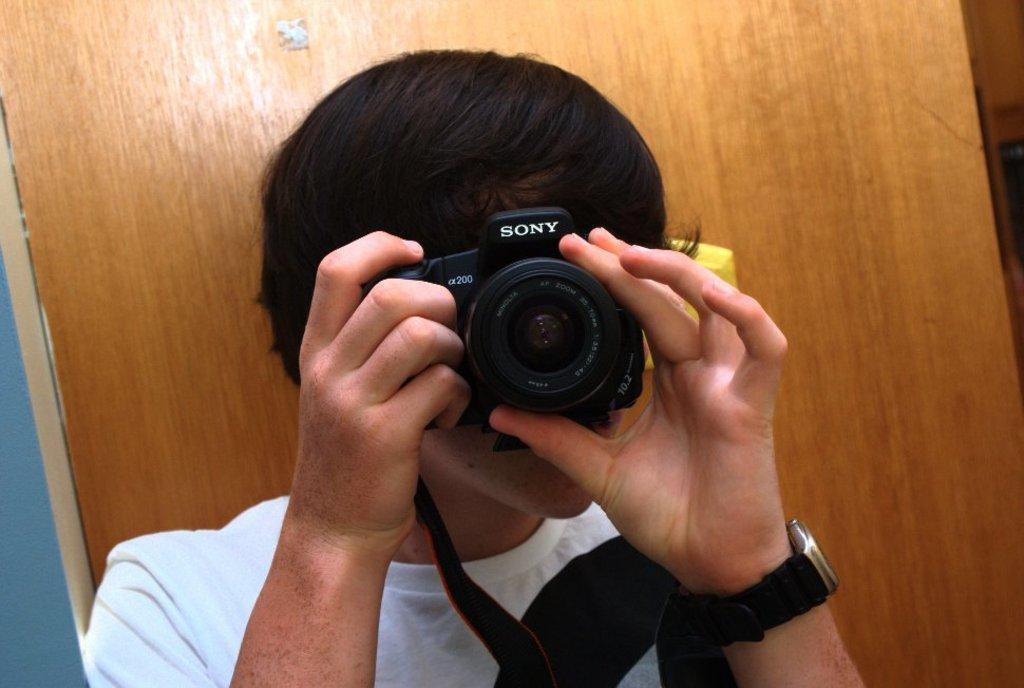Can you describe this image briefly? This man wore white t-shirt and holding a camera. I think this man is trying to take a snap from this camera. 